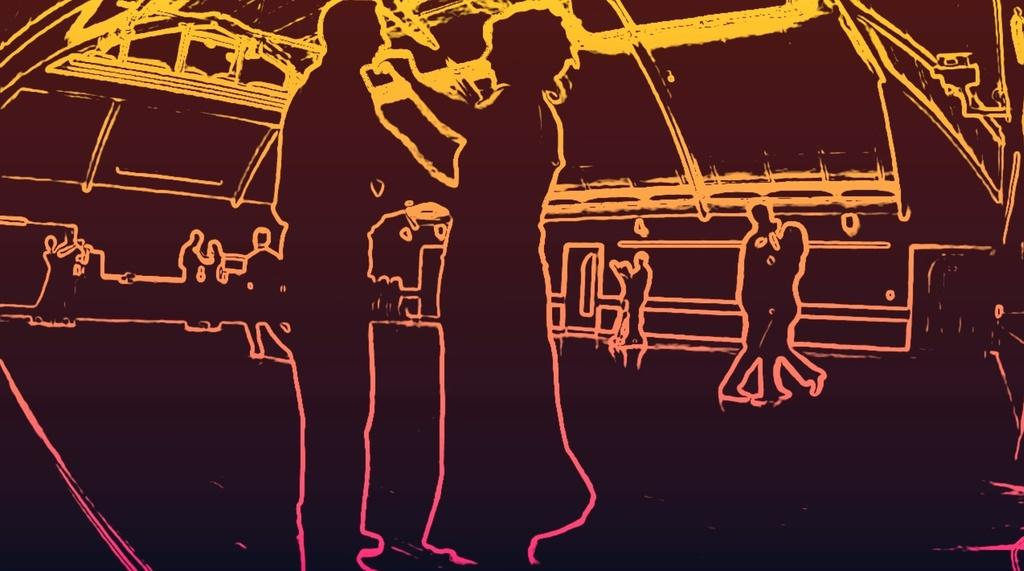What is the main subject of the image? There is an art piece in the image. What is the art piece depicting? The art piece depicts people dancing. What type of treatment is being administered to the person with a sore throat in the image? There is no person with a sore throat or any treatment being administered in the image; it only depicts people dancing. How many feathers can be seen on the dancers in the image? There are no feathers visible on the dancers in the image; it only depicts people dancing. 